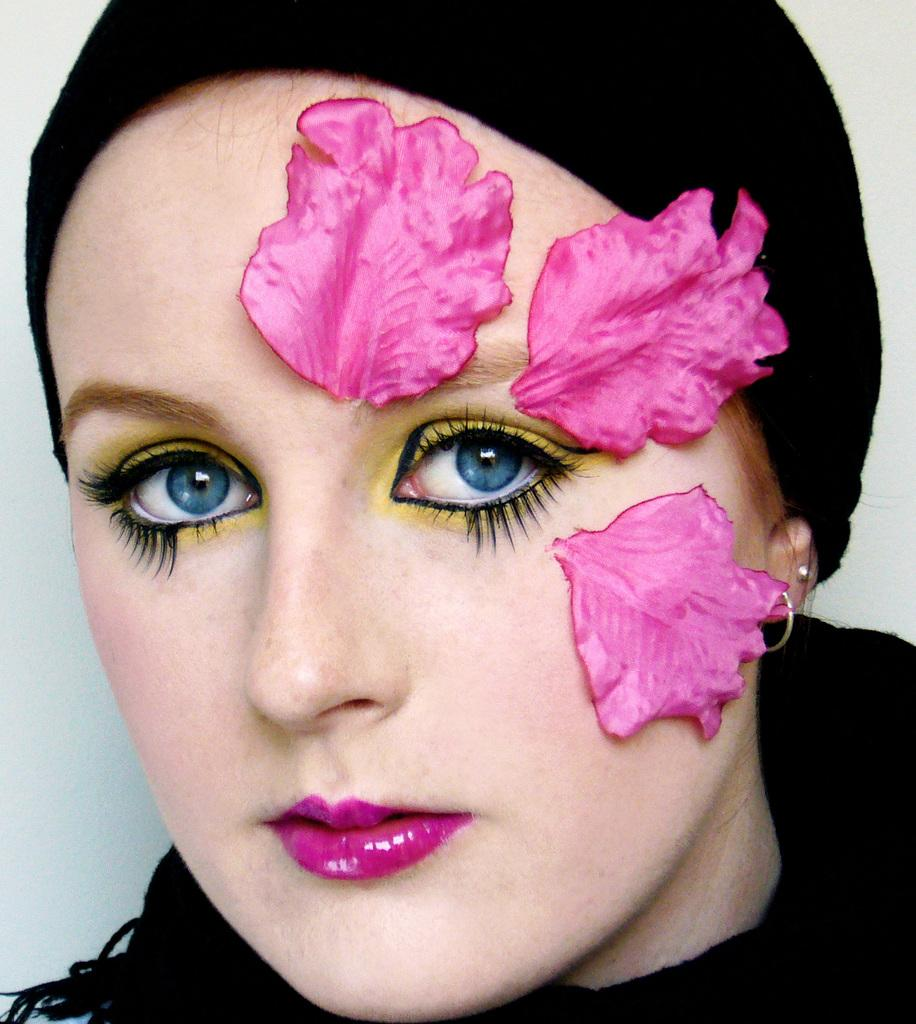What is the main subject of the image? The main subject of the image is a woman. Can you describe the woman's appearance in the image? The woman is wearing different makeup in the image. What type of substance is the woman carrying in a sack in the image? There is no sack or substance present in the image; the woman is only wearing different makeup. 